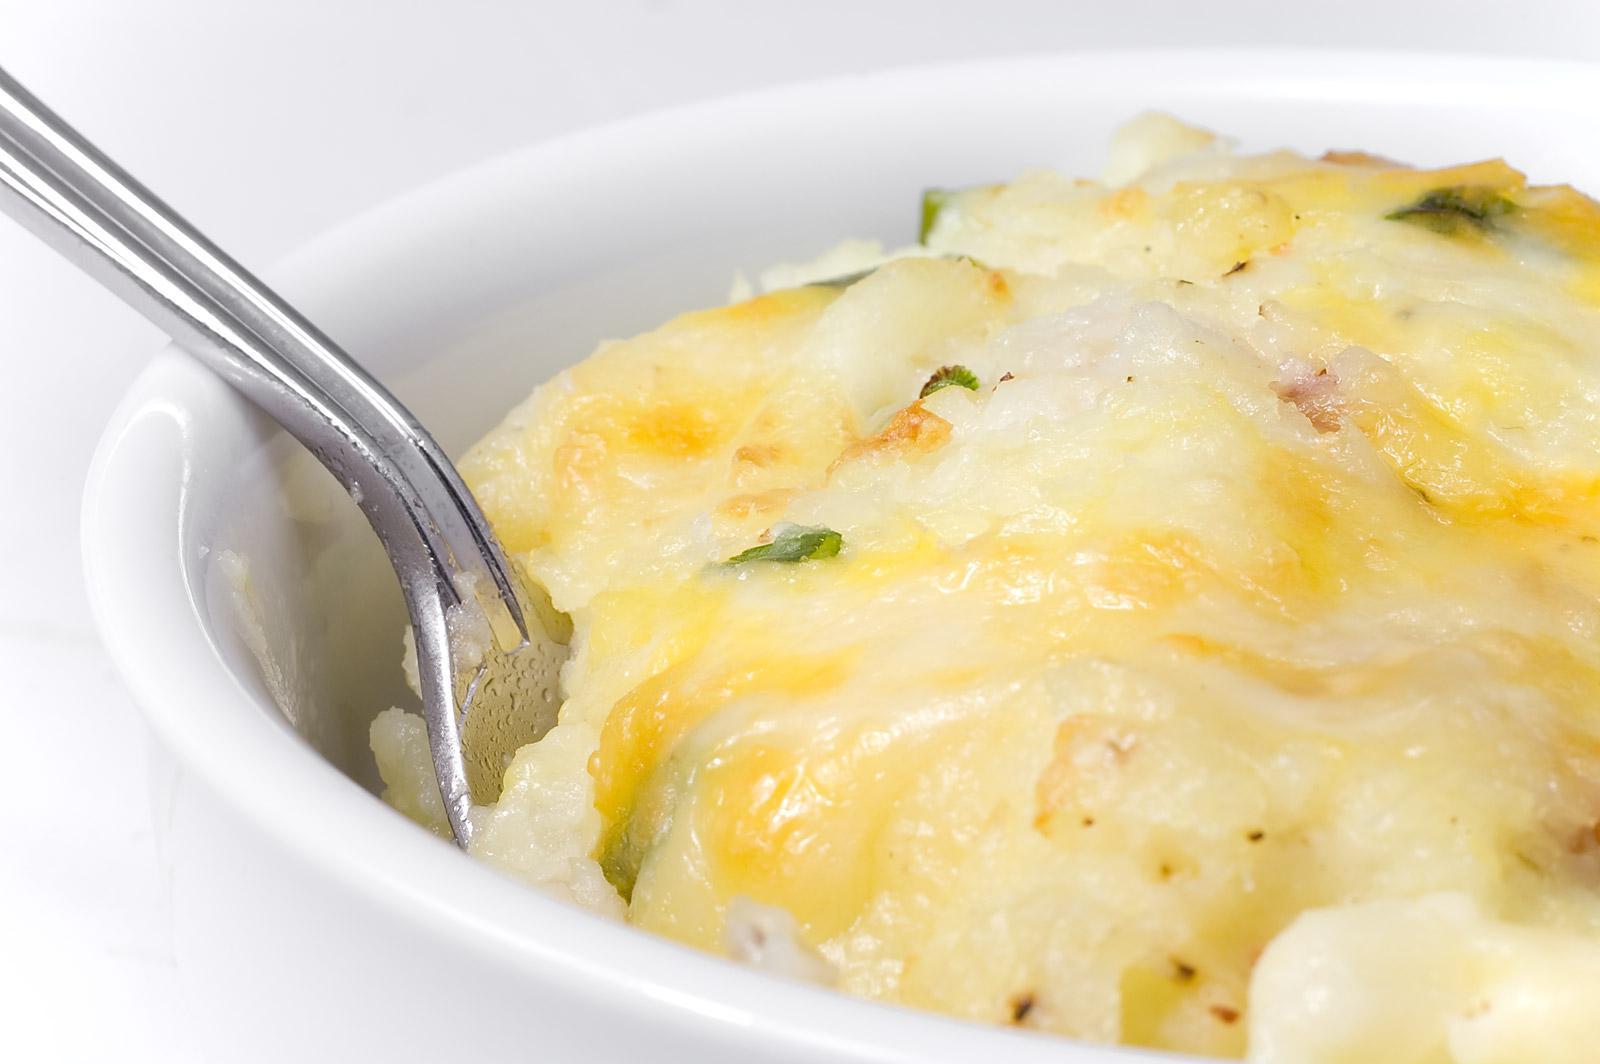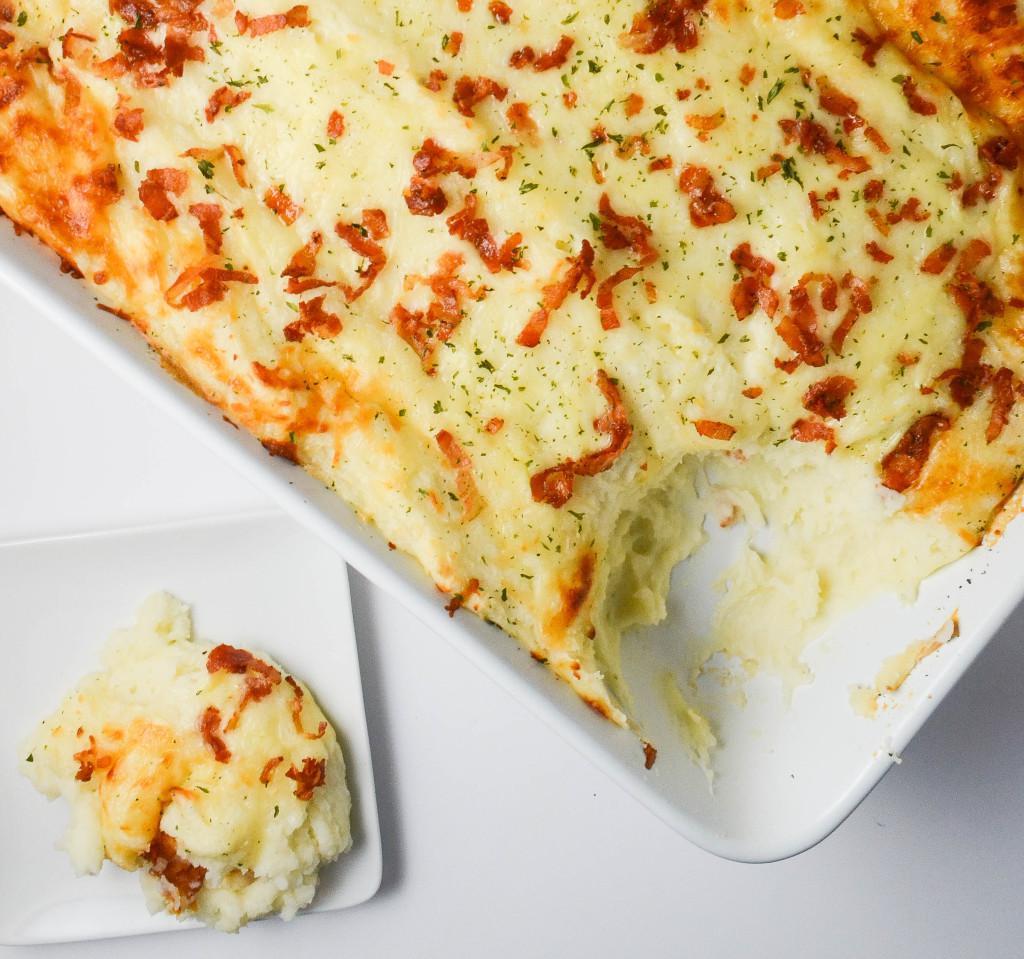The first image is the image on the left, the second image is the image on the right. Assess this claim about the two images: "There is a silvers spoon sitting in a white bowl of food.". Correct or not? Answer yes or no. Yes. The first image is the image on the left, the second image is the image on the right. Considering the images on both sides, is "An eating utensil is lifted above a bowl of food." valid? Answer yes or no. No. 